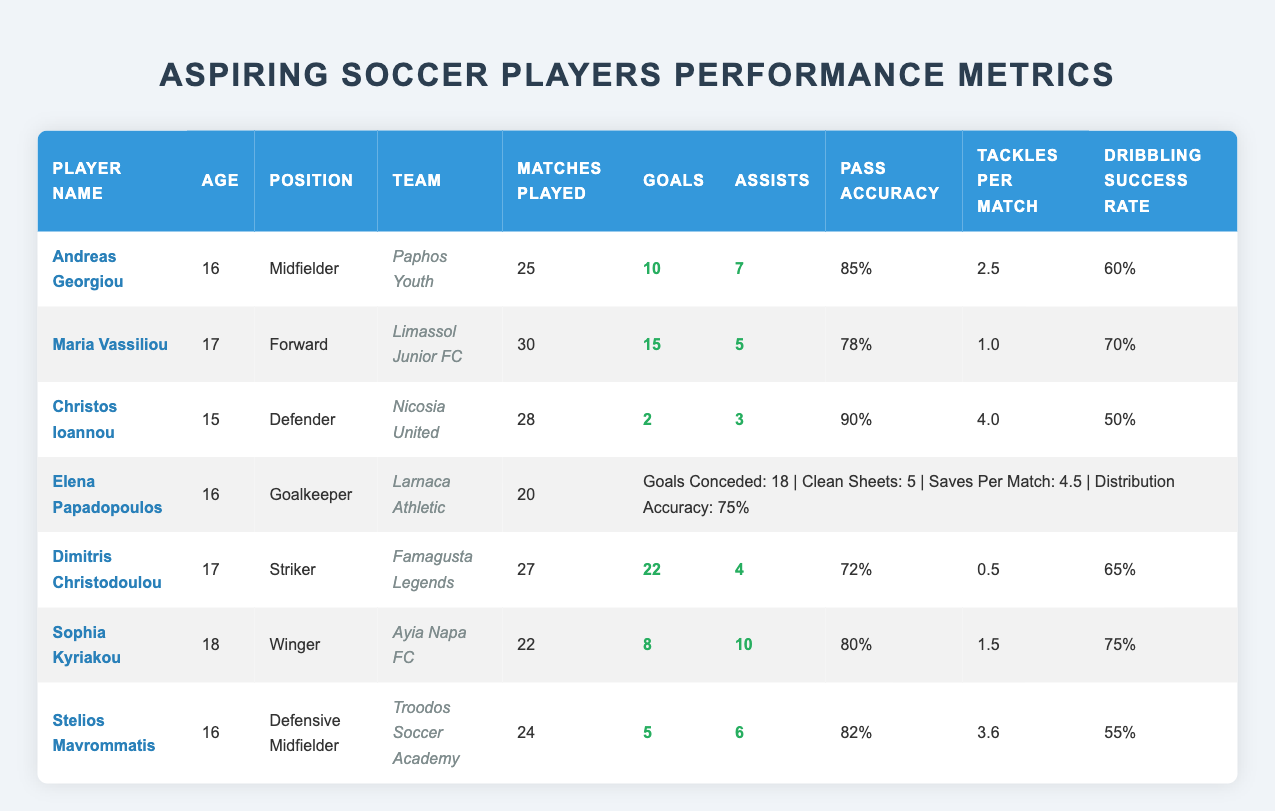What is the highest number of goals scored by a player? The highest number of goals scored is found by looking at the "Goals" column. The highest value is 22, which belongs to Dimitris Christodoulou.
Answer: 22 How many assists did Sophia Kyriakou provide? Sophia Kyriakou's assists can be directly found in the "Assists" column, which has a value of 10.
Answer: 10 Who has the highest pass accuracy? To determine who has the highest pass accuracy, we look at the "Pass Accuracy" column. Christos Ioannou has the highest value of 90%.
Answer: Christos Ioannou What is the average number of goals scored by the players? To find the average goals, we need to sum the goals scored by all players: 10 + 15 + 2 + 22 + 8 + 5 = 62. There are 7 players, so the average is 62/7 = approximately 8.86.
Answer: 8.86 Is Elena Papadopoulos on a team with more than 5 clean sheets? Elena Papadopoulos has 5 clean sheets, which does not exceed 5. Hence, the answer is no.
Answer: No Which player has the most tackles per match? We examine the "Tackles Per Match" column for the highest value. Christos Ioannou has the most with 4.0 tackles per match.
Answer: Christos Ioannou What is the total number of matches played by all players combined? To find the total matches played, we sum the values in the "Matches Played" column: 25 + 30 + 28 + 20 + 27 + 22 + 24 = 176.
Answer: 176 Which player has the lowest dribbling success rate? The lowest dribbling success rate can be found by checking the "Dribbling Success Rate" column. Stelios Mavrommatis has the lowest at 55%.
Answer: Stelios Mavrommatis If you combine the goals scored by Andreas Georgiou and Dimitris Christodoulou, how many do they have in total? To find the combined goals, we add the goals scored by both players: 10 (Andreas Georgiou) + 22 (Dimitris Christodoulou) = 32.
Answer: 32 